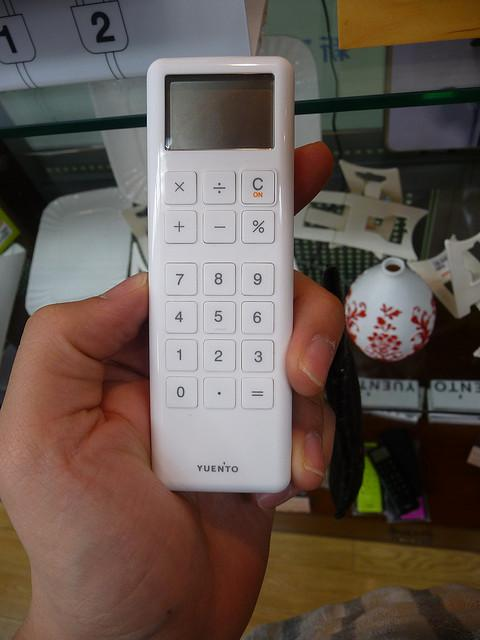What is this device used for?

Choices:
A) phone calls
B) music
C) arithmetic
D) video games arithmetic 